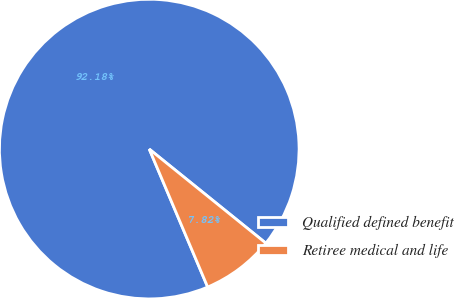Convert chart. <chart><loc_0><loc_0><loc_500><loc_500><pie_chart><fcel>Qualified defined benefit<fcel>Retiree medical and life<nl><fcel>92.18%<fcel>7.82%<nl></chart> 